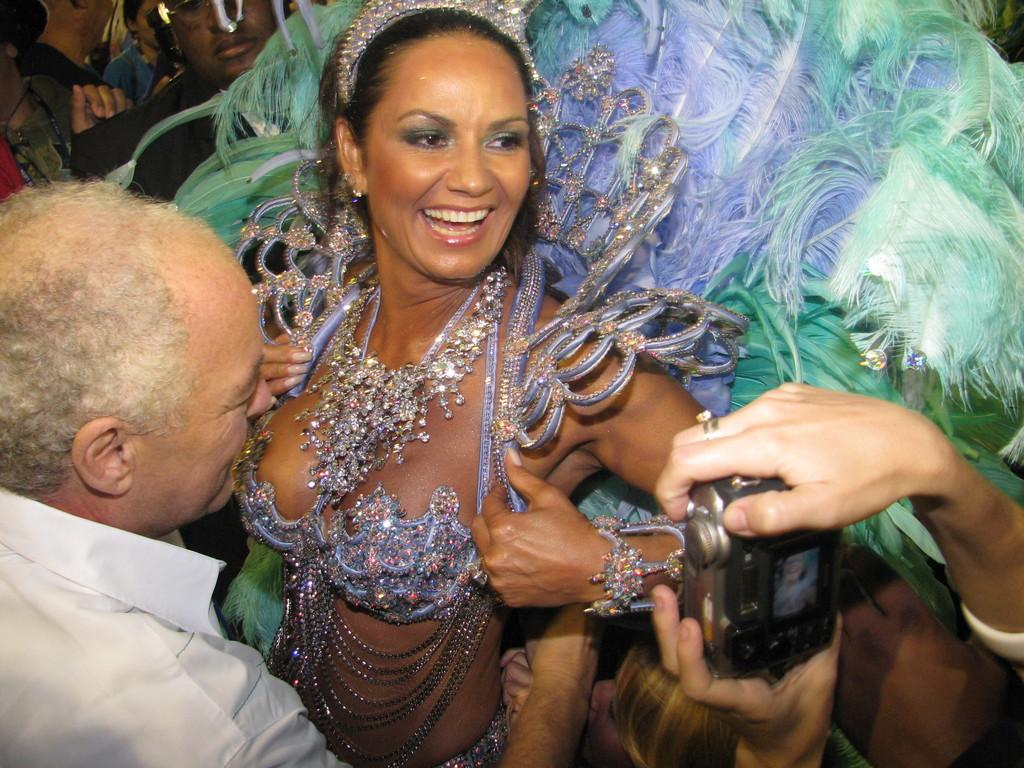What is the woman in the image wearing? The woman in the image is wearing a costume with feathers and jewelry. What is happening in the image? A person is taking a photograph of the woman. Who else is present in the image? There is a man standing in front of the woman. What type of cloud can be seen in the image? There is no cloud present in the image. What advice is the man giving to the woman in the image? There is no indication in the image that the man is giving advice to the woman. 